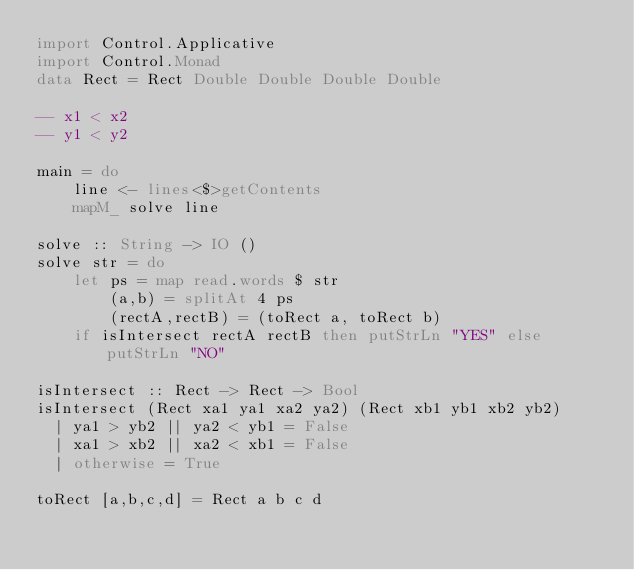Convert code to text. <code><loc_0><loc_0><loc_500><loc_500><_Haskell_>import Control.Applicative
import Control.Monad
data Rect = Rect Double Double Double Double

-- x1 < x2
-- y1 < y2

main = do
    line <- lines<$>getContents
    mapM_ solve line

solve :: String -> IO ()
solve str = do
    let ps = map read.words $ str
        (a,b) = splitAt 4 ps
        (rectA,rectB) = (toRect a, toRect b)
    if isIntersect rectA rectB then putStrLn "YES" else putStrLn "NO"

isIntersect :: Rect -> Rect -> Bool
isIntersect (Rect xa1 ya1 xa2 ya2) (Rect xb1 yb1 xb2 yb2)
  | ya1 > yb2 || ya2 < yb1 = False
  | xa1 > xb2 || xa2 < xb1 = False
  | otherwise = True

toRect [a,b,c,d] = Rect a b c d</code> 